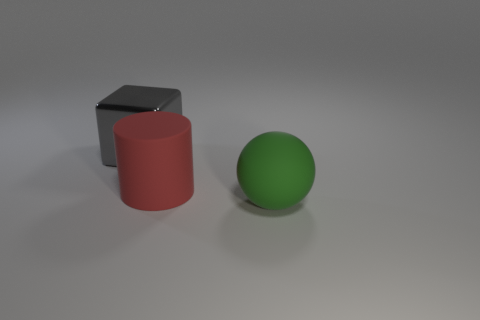The matte cylinder that is the same size as the matte sphere is what color?
Provide a succinct answer. Red. Does the big red matte object have the same shape as the large matte thing that is in front of the red cylinder?
Provide a short and direct response. No. How many things are either rubber objects behind the large green ball or rubber things to the left of the large green thing?
Your response must be concise. 1. There is a big matte thing in front of the red rubber cylinder; what shape is it?
Provide a succinct answer. Sphere. There is a big thing left of the matte cylinder; does it have the same shape as the big red rubber thing?
Your answer should be compact. No. How many objects are either big things on the right side of the gray thing or tiny red rubber spheres?
Ensure brevity in your answer.  2. Is there any other thing of the same color as the rubber cylinder?
Ensure brevity in your answer.  No. There is a rubber thing behind the big green rubber object; how big is it?
Offer a very short reply. Large. There is a big metal object; is it the same color as the matte object that is to the left of the large green object?
Ensure brevity in your answer.  No. What number of other things are there of the same material as the red cylinder
Make the answer very short. 1. 